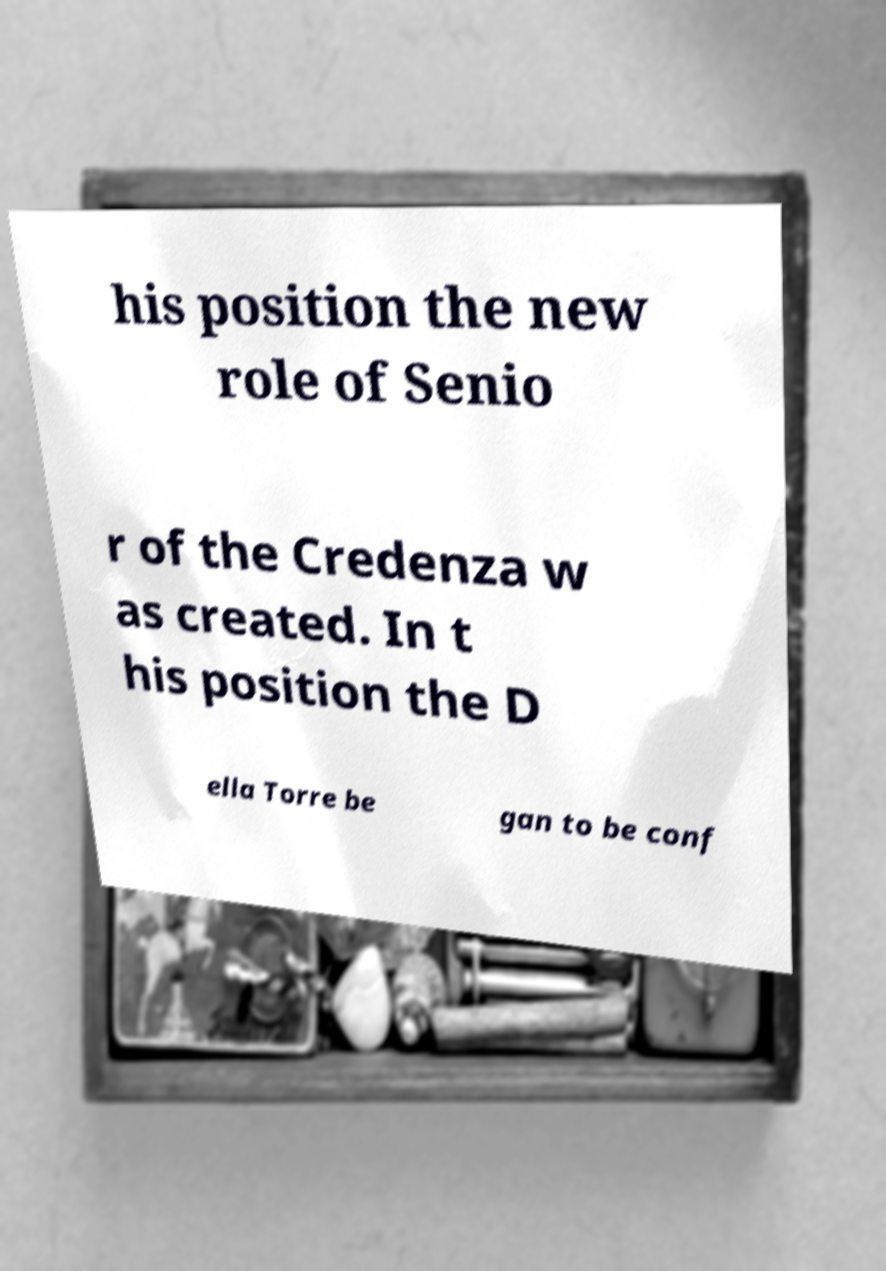Could you extract and type out the text from this image? his position the new role of Senio r of the Credenza w as created. In t his position the D ella Torre be gan to be conf 